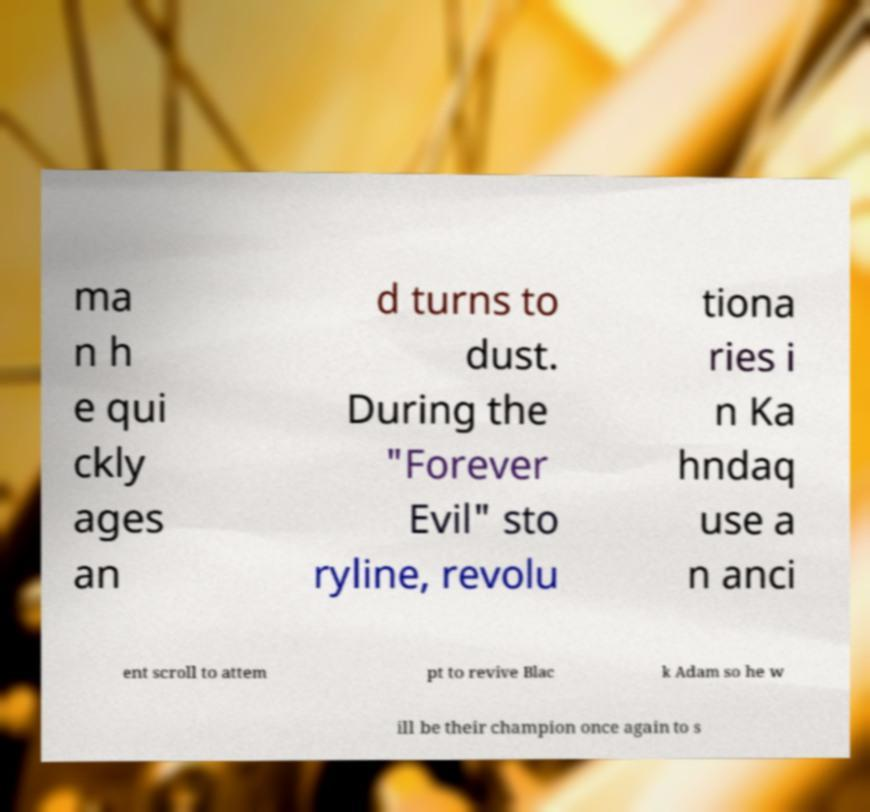Could you extract and type out the text from this image? ma n h e qui ckly ages an d turns to dust. During the "Forever Evil" sto ryline, revolu tiona ries i n Ka hndaq use a n anci ent scroll to attem pt to revive Blac k Adam so he w ill be their champion once again to s 